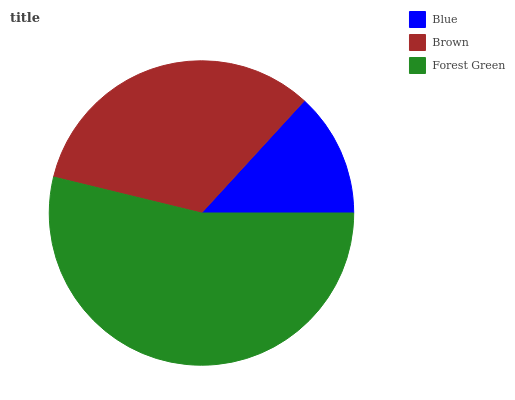Is Blue the minimum?
Answer yes or no. Yes. Is Forest Green the maximum?
Answer yes or no. Yes. Is Brown the minimum?
Answer yes or no. No. Is Brown the maximum?
Answer yes or no. No. Is Brown greater than Blue?
Answer yes or no. Yes. Is Blue less than Brown?
Answer yes or no. Yes. Is Blue greater than Brown?
Answer yes or no. No. Is Brown less than Blue?
Answer yes or no. No. Is Brown the high median?
Answer yes or no. Yes. Is Brown the low median?
Answer yes or no. Yes. Is Blue the high median?
Answer yes or no. No. Is Blue the low median?
Answer yes or no. No. 